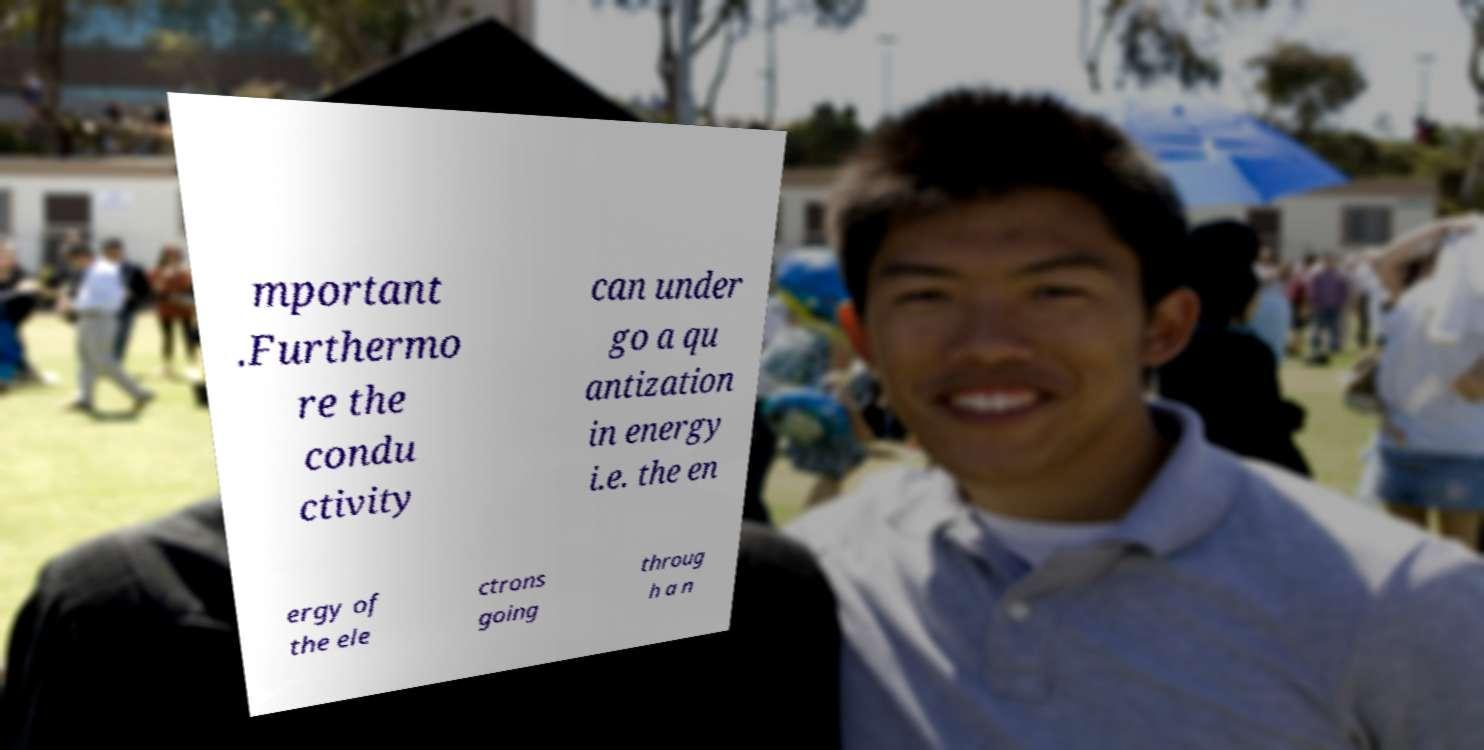Could you extract and type out the text from this image? mportant .Furthermo re the condu ctivity can under go a qu antization in energy i.e. the en ergy of the ele ctrons going throug h a n 